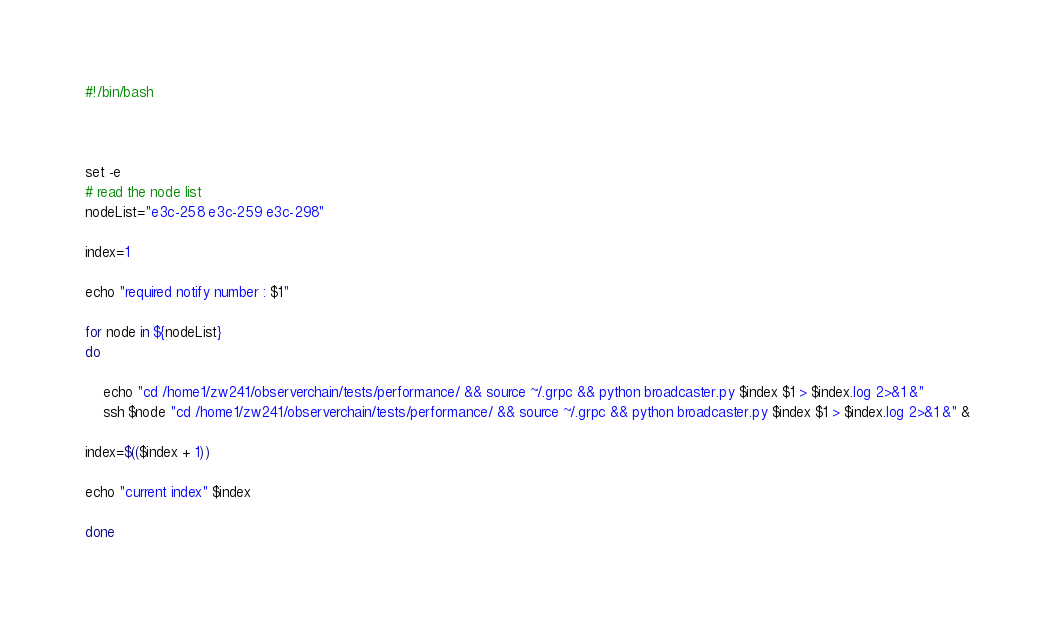Convert code to text. <code><loc_0><loc_0><loc_500><loc_500><_Bash_>#!/bin/bash



set -e
# read the node list
nodeList="e3c-258 e3c-259 e3c-298"

index=1

echo "required notify number : $1"

for node in ${nodeList}
do

    echo "cd /home1/zw241/observerchain/tests/performance/ && source ~/.grpc && python broadcaster.py $index $1 > $index.log 2>&1 &"
    ssh $node "cd /home1/zw241/observerchain/tests/performance/ && source ~/.grpc && python broadcaster.py $index $1 > $index.log 2>&1 &" &
    
index=$(($index + 1))

echo "current index" $index

done


</code> 